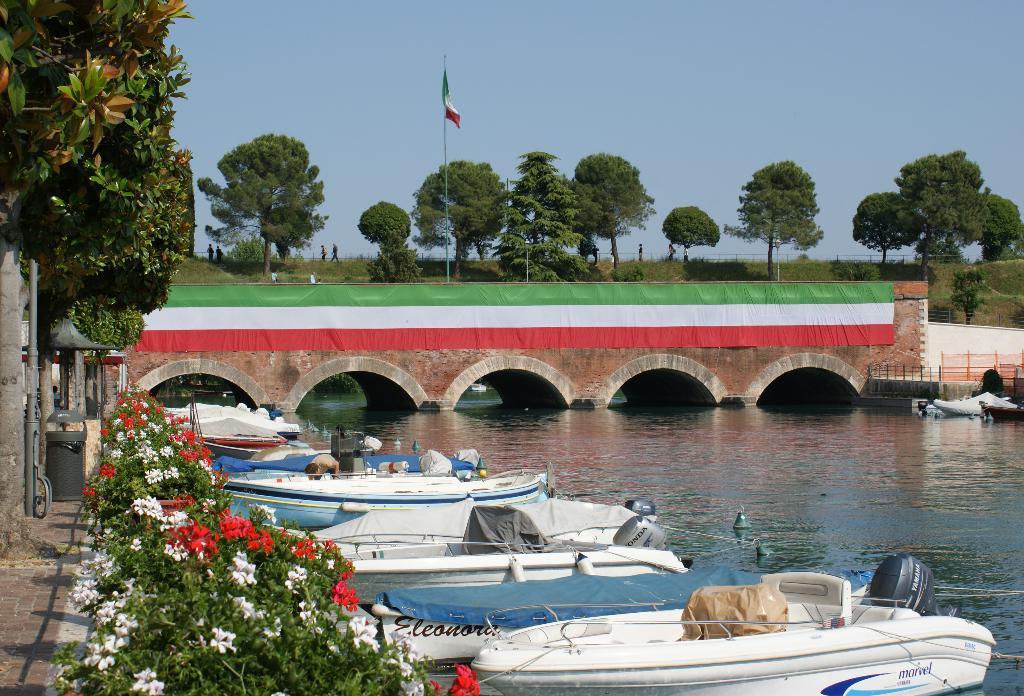How would you summarize this image in a sentence or two? There are boats on the surface of water and plants are present at the bottom of this image. There is a bridge and trees in the middle of this image and there is a sky at the top of this image. 